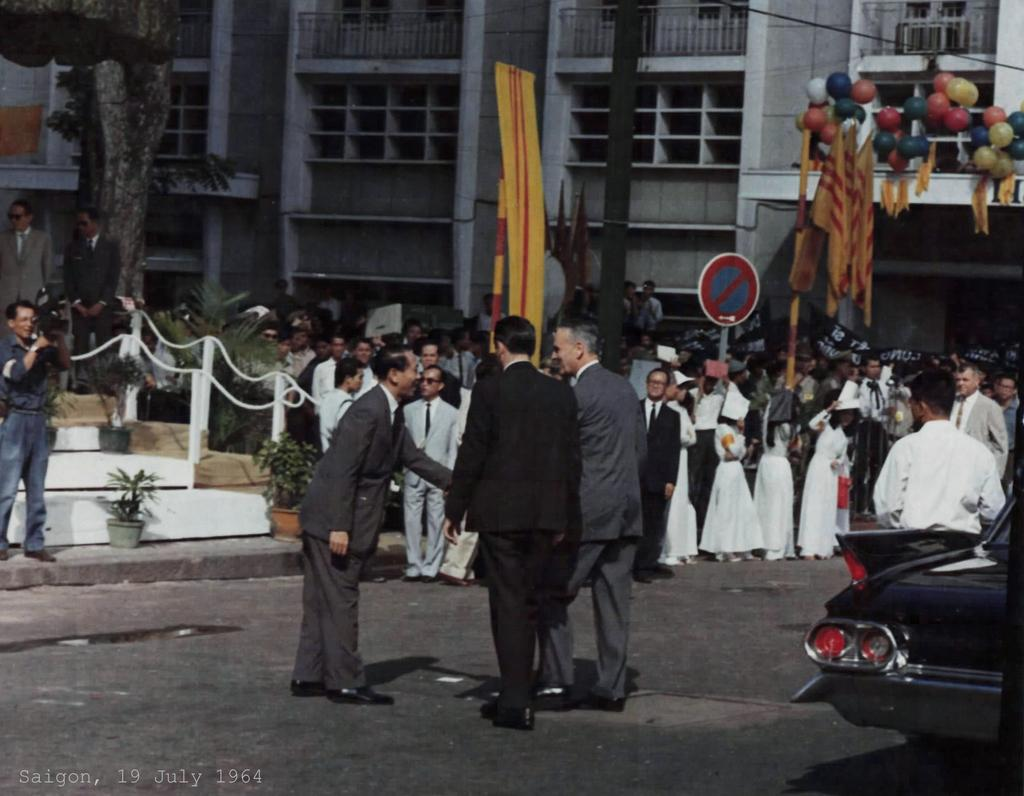How many people are in the group that is visible in the image? There is a group of people standing in the image, but the exact number is not specified. What type of structures can be seen in the image? There are buildings in the image. What architectural feature is present in the image? There are windows in the image. What is attached to the buildings in the image? There are flags in the image. What decorative items can be seen in the image? There are balloons in the image. What is a functional element in the image? There are stairs in the image. What type of plants are present in the image? There are flower pots and trees in the image. What mode of transportation is visible in the image? There is a vehicle in the image. What are some people in the group doing in the image? Some people are holding cameras in the image. What type of brass instrument is being played by the man in the image? There is no brass instrument or man playing an instrument present in the image. What type of flesh can be seen on the people in the image? The question is inappropriate and not relevant to the image, as it focuses on a personal and irrelevant aspect of the people in the image. 